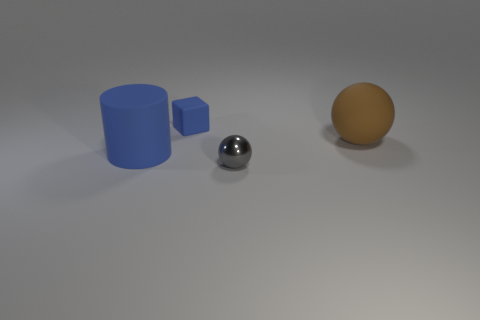Is there anything else that is made of the same material as the gray object?
Provide a succinct answer. No. Is the number of gray spheres greater than the number of tiny cyan balls?
Make the answer very short. Yes. What number of objects are gray metal spheres or spheres in front of the cylinder?
Keep it short and to the point. 1. Is the shiny sphere the same size as the brown sphere?
Your answer should be very brief. No. Are there any rubber spheres on the right side of the matte cube?
Your response must be concise. Yes. What size is the object that is left of the big brown rubber ball and on the right side of the small matte cube?
Offer a terse response. Small. What number of things are either small green matte cylinders or large blue matte cylinders?
Give a very brief answer. 1. There is a blue block; does it have the same size as the ball to the left of the large matte ball?
Your answer should be compact. Yes. What is the size of the blue object left of the blue matte thing that is behind the large object on the left side of the small metal object?
Offer a very short reply. Large. Are any metallic things visible?
Your answer should be compact. Yes. 